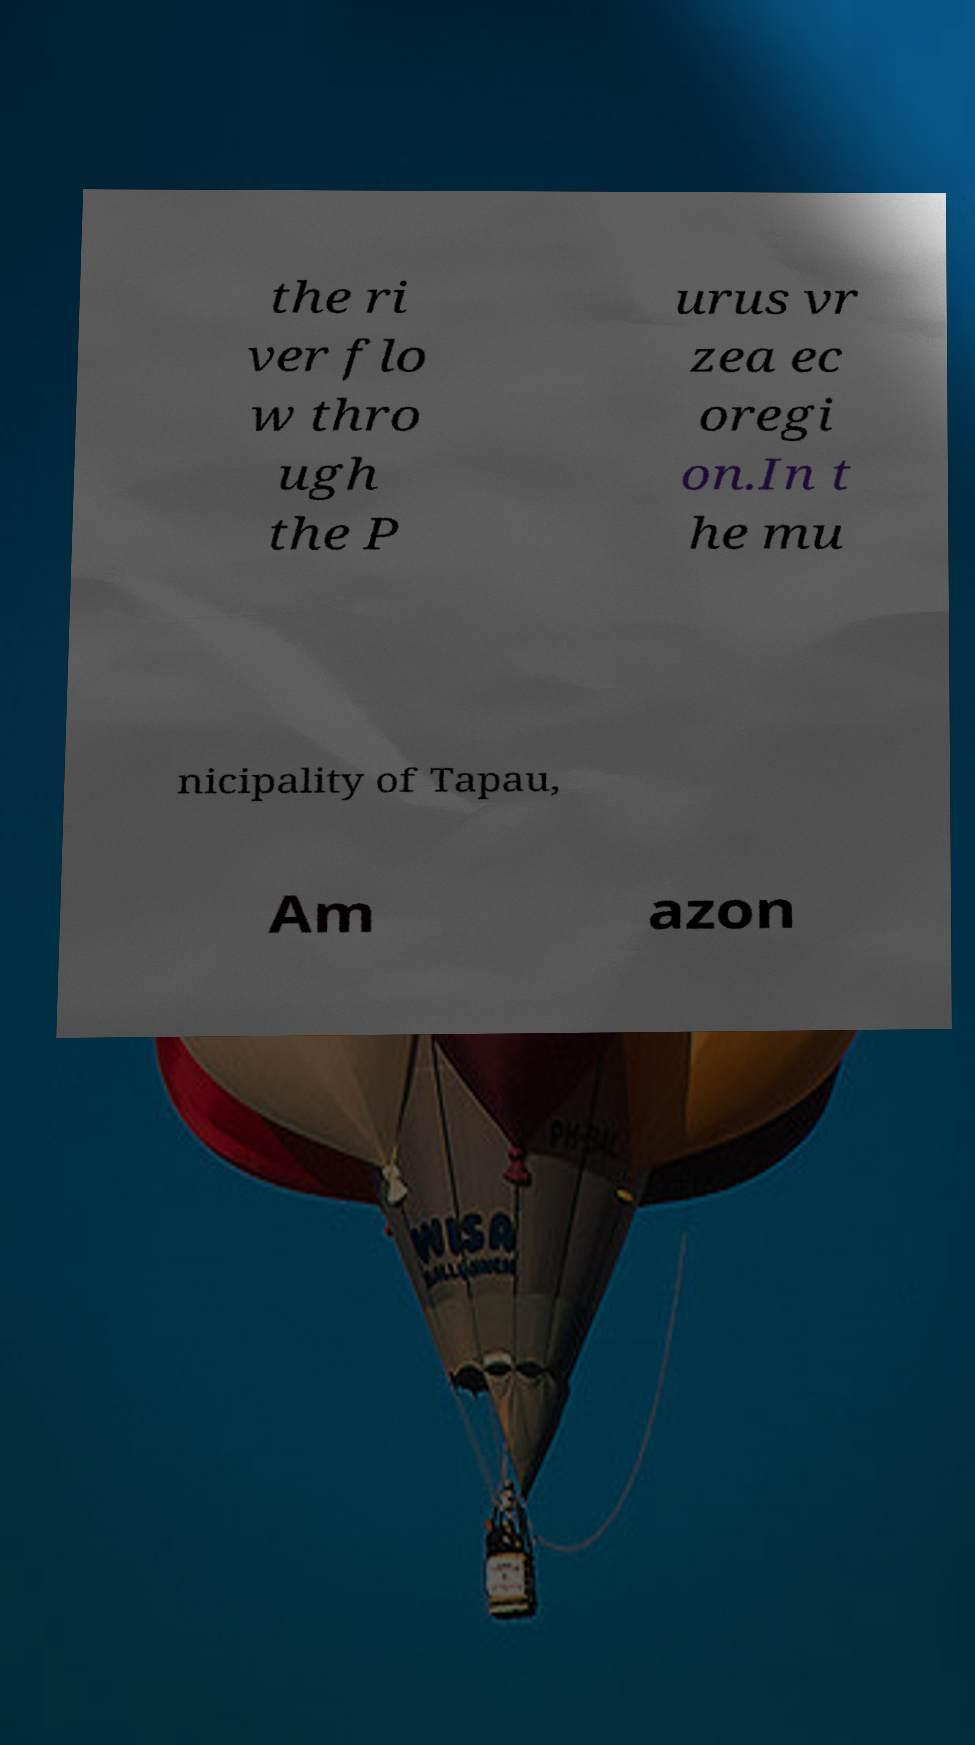What messages or text are displayed in this image? I need them in a readable, typed format. the ri ver flo w thro ugh the P urus vr zea ec oregi on.In t he mu nicipality of Tapau, Am azon 